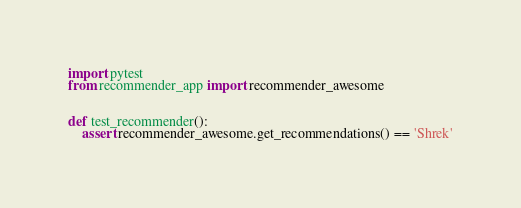Convert code to text. <code><loc_0><loc_0><loc_500><loc_500><_Python_>

import pytest
from recommender_app import recommender_awesome


def test_recommender():
    assert recommender_awesome.get_recommendations() == 'Shrek'
</code> 